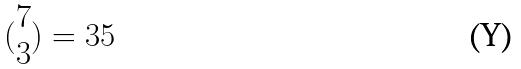Convert formula to latex. <formula><loc_0><loc_0><loc_500><loc_500>( \begin{matrix} 7 \\ 3 \end{matrix} ) = 3 5</formula> 